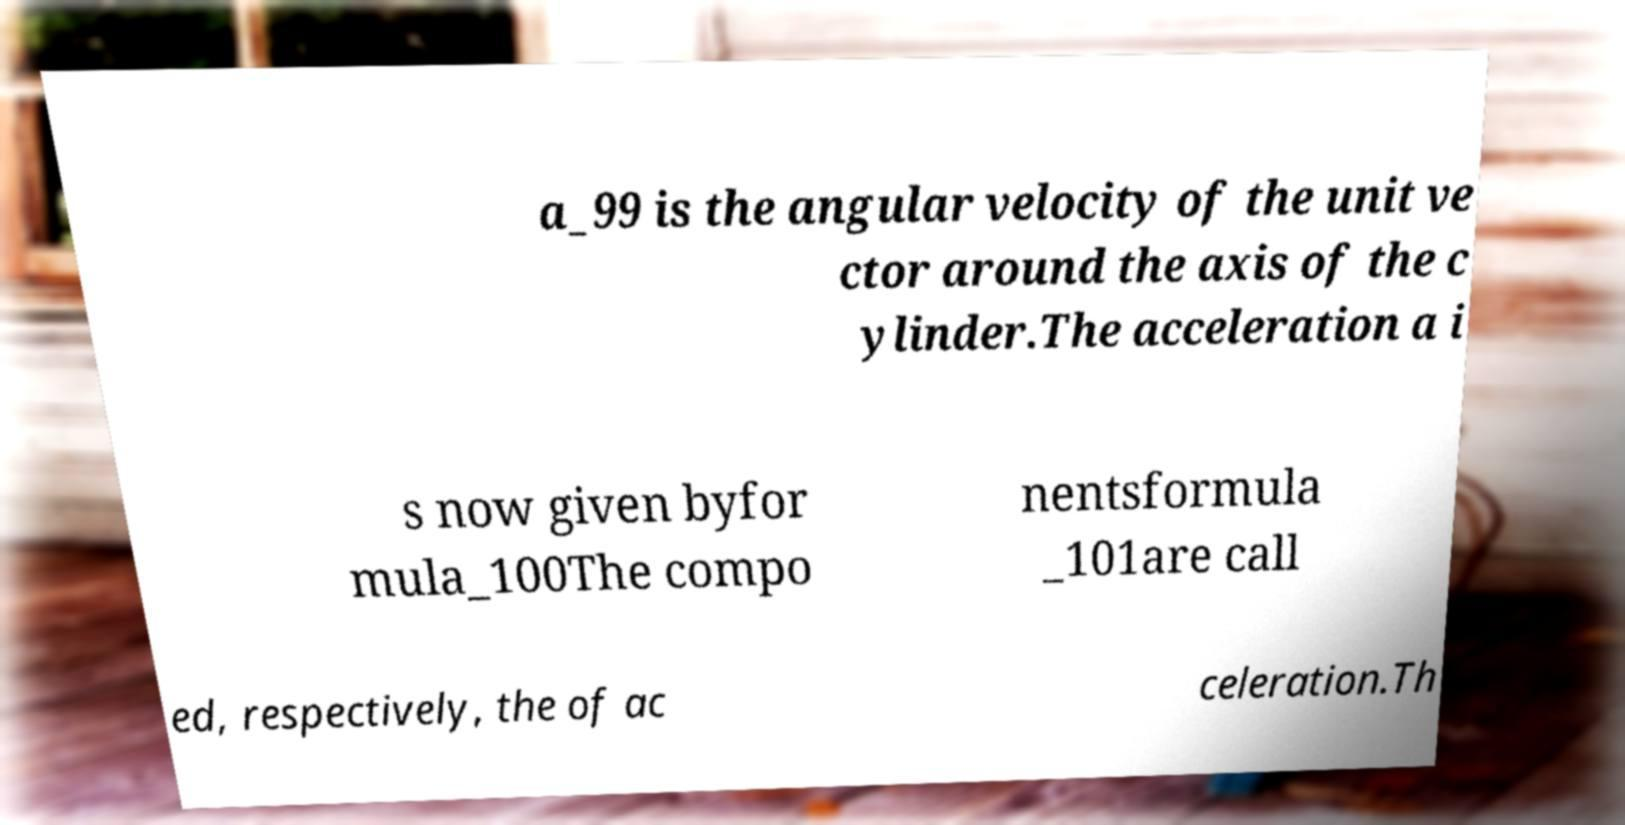What messages or text are displayed in this image? I need them in a readable, typed format. a_99 is the angular velocity of the unit ve ctor around the axis of the c ylinder.The acceleration a i s now given byfor mula_100The compo nentsformula _101are call ed, respectively, the of ac celeration.Th 